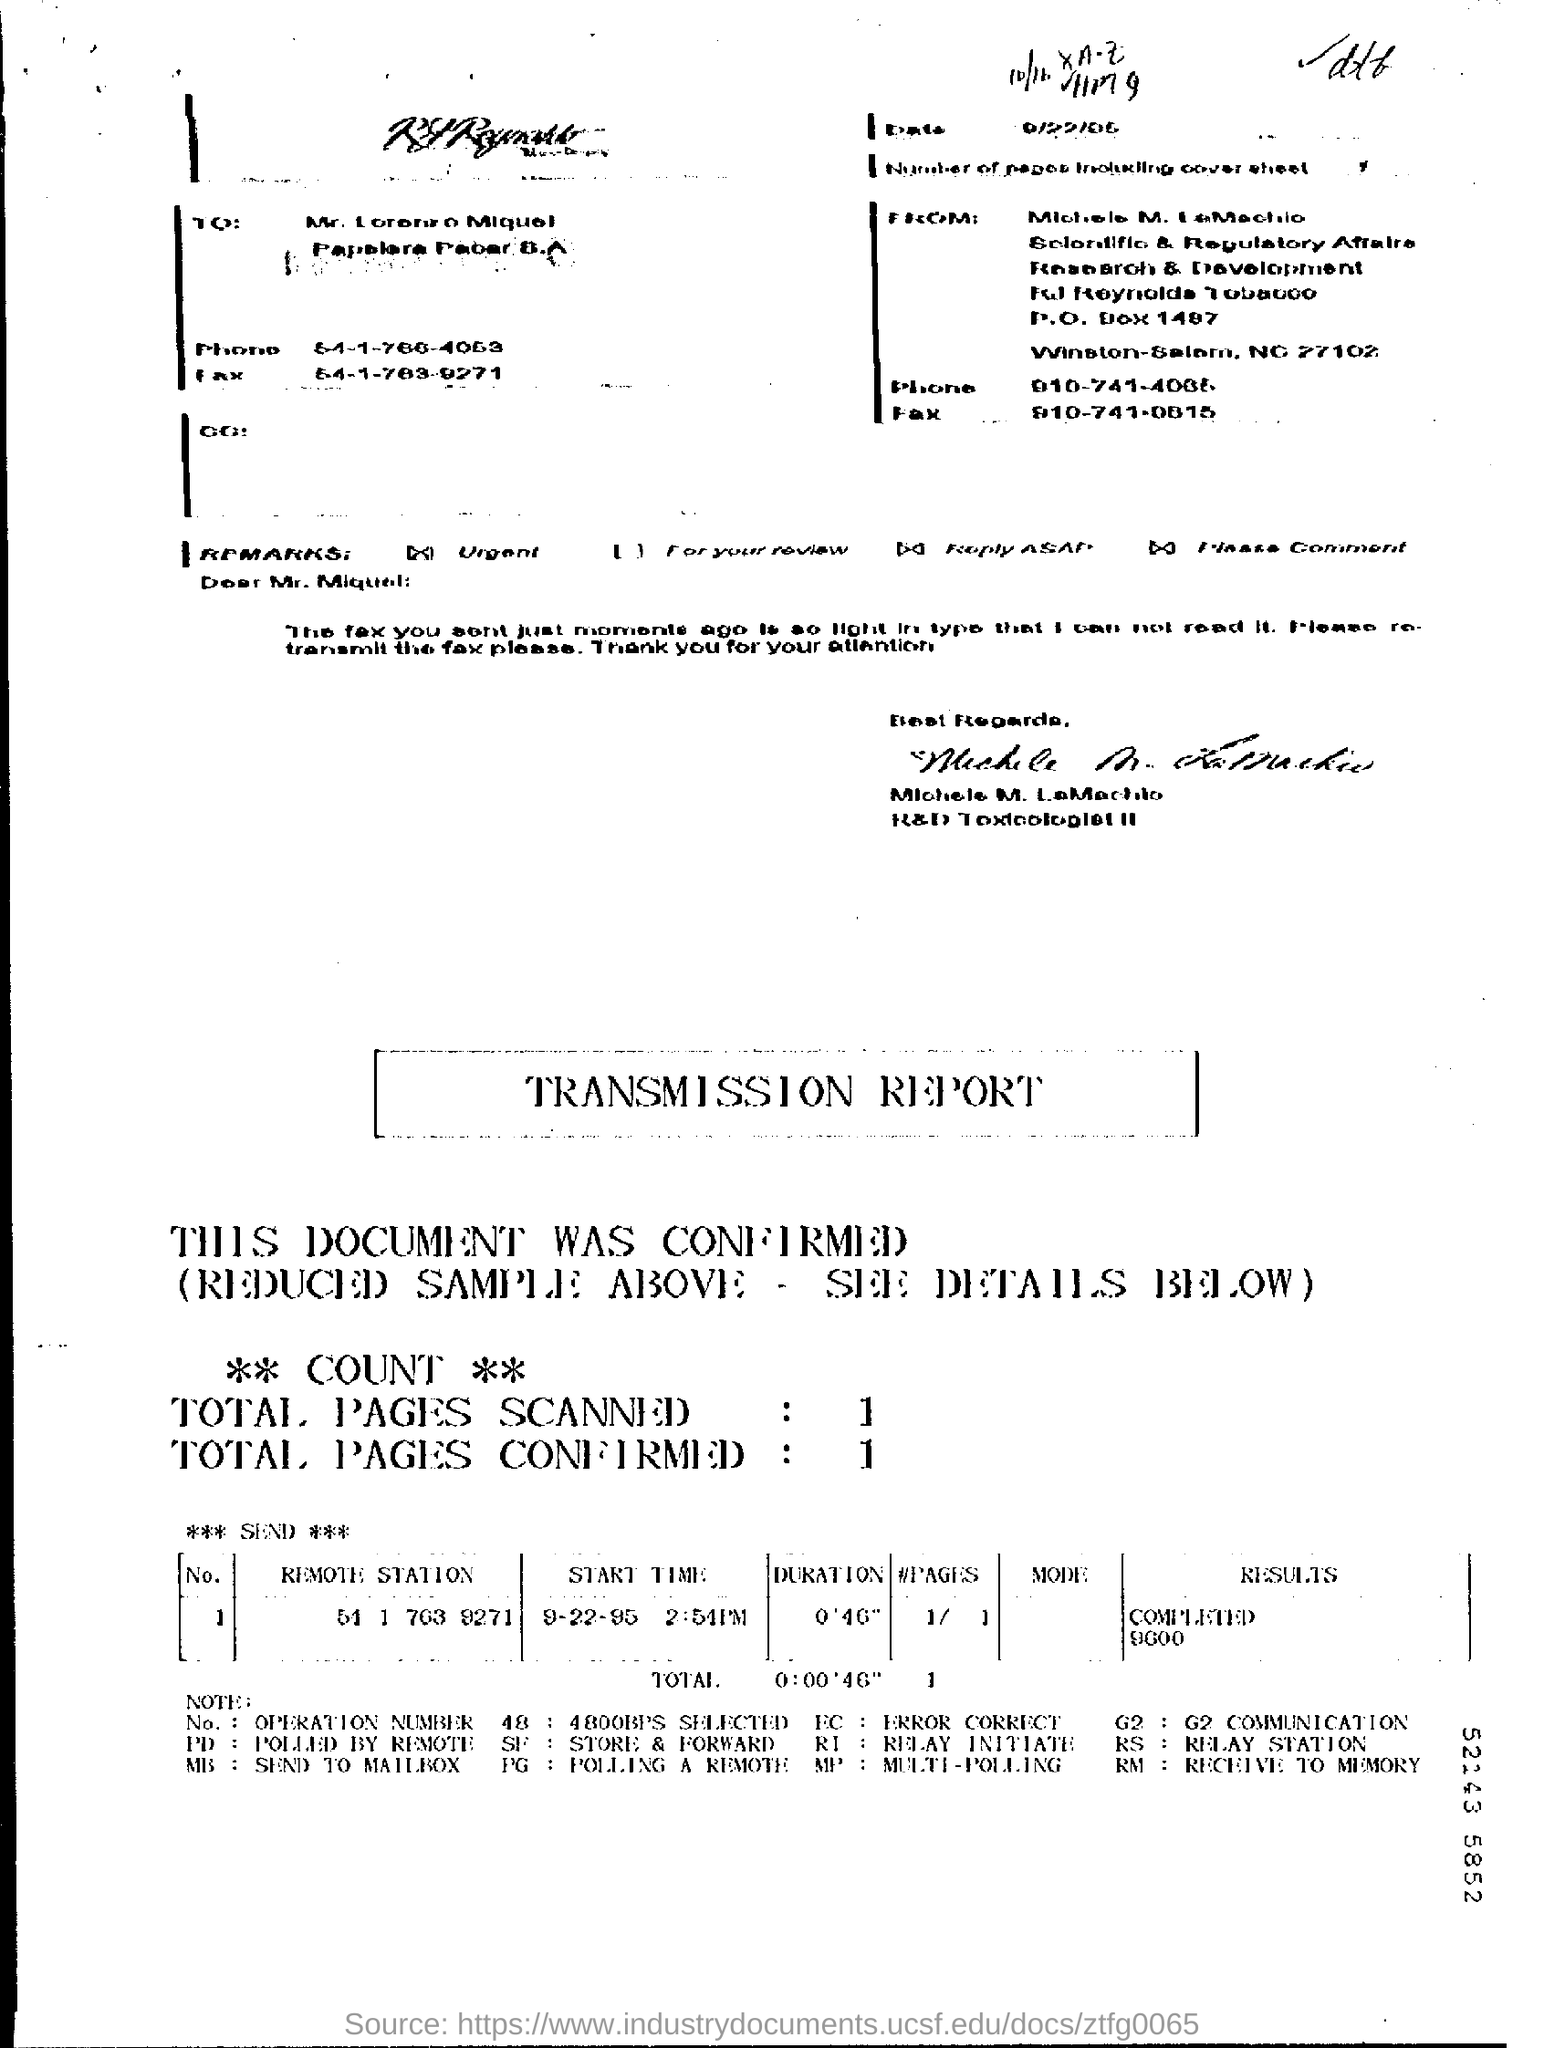What is the "Start Time" for "Remote Station" "51 1 763 9271"?
Your answer should be very brief. 2:54PM. What is the "Results" for "Remote Station" "51 1 763 9271"?
Your response must be concise. COMPLETED 9600. 